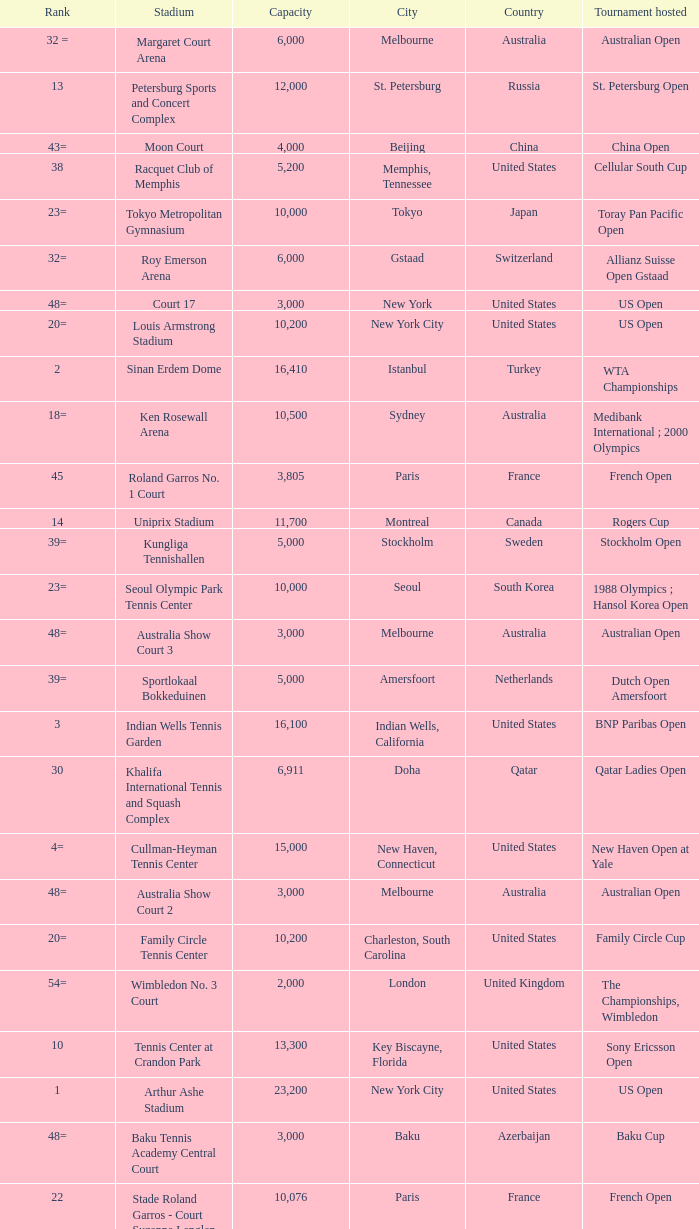Can you parse all the data within this table? {'header': ['Rank', 'Stadium', 'Capacity', 'City', 'Country', 'Tournament hosted'], 'rows': [['32 =', 'Margaret Court Arena', '6,000', 'Melbourne', 'Australia', 'Australian Open'], ['13', 'Petersburg Sports and Concert Complex', '12,000', 'St. Petersburg', 'Russia', 'St. Petersburg Open'], ['43=', 'Moon Court', '4,000', 'Beijing', 'China', 'China Open'], ['38', 'Racquet Club of Memphis', '5,200', 'Memphis, Tennessee', 'United States', 'Cellular South Cup'], ['23=', 'Tokyo Metropolitan Gymnasium', '10,000', 'Tokyo', 'Japan', 'Toray Pan Pacific Open'], ['32=', 'Roy Emerson Arena', '6,000', 'Gstaad', 'Switzerland', 'Allianz Suisse Open Gstaad'], ['48=', 'Court 17', '3,000', 'New York', 'United States', 'US Open'], ['20=', 'Louis Armstrong Stadium', '10,200', 'New York City', 'United States', 'US Open'], ['2', 'Sinan Erdem Dome', '16,410', 'Istanbul', 'Turkey', 'WTA Championships'], ['18=', 'Ken Rosewall Arena', '10,500', 'Sydney', 'Australia', 'Medibank International ; 2000 Olympics'], ['45', 'Roland Garros No. 1 Court', '3,805', 'Paris', 'France', 'French Open'], ['14', 'Uniprix Stadium', '11,700', 'Montreal', 'Canada', 'Rogers Cup'], ['39=', 'Kungliga Tennishallen', '5,000', 'Stockholm', 'Sweden', 'Stockholm Open'], ['23=', 'Seoul Olympic Park Tennis Center', '10,000', 'Seoul', 'South Korea', '1988 Olympics ; Hansol Korea Open'], ['48=', 'Australia Show Court 3', '3,000', 'Melbourne', 'Australia', 'Australian Open'], ['39=', 'Sportlokaal Bokkeduinen', '5,000', 'Amersfoort', 'Netherlands', 'Dutch Open Amersfoort'], ['3', 'Indian Wells Tennis Garden', '16,100', 'Indian Wells, California', 'United States', 'BNP Paribas Open'], ['30', 'Khalifa International Tennis and Squash Complex', '6,911', 'Doha', 'Qatar', 'Qatar Ladies Open'], ['4=', 'Cullman-Heyman Tennis Center', '15,000', 'New Haven, Connecticut', 'United States', 'New Haven Open at Yale'], ['48=', 'Australia Show Court 2', '3,000', 'Melbourne', 'Australia', 'Australian Open'], ['20=', 'Family Circle Tennis Center', '10,200', 'Charleston, South Carolina', 'United States', 'Family Circle Cup'], ['54=', 'Wimbledon No. 3 Court', '2,000', 'London', 'United Kingdom', 'The Championships, Wimbledon'], ['10', 'Tennis Center at Crandon Park', '13,300', 'Key Biscayne, Florida', 'United States', 'Sony Ericsson Open'], ['1', 'Arthur Ashe Stadium', '23,200', 'New York City', 'United States', 'US Open'], ['48=', 'Baku Tennis Academy Central Court', '3,000', 'Baku', 'Azerbaijan', 'Baku Cup'], ['22', 'Stade Roland Garros - Court Suzanne Lenglen', '10,076', 'Paris', 'France', 'French Open'], ['10=', 'Foro Italico, Campo Centrale', '12,500', 'Rome', 'Italy', "Internazionali d'Italia"], ['23=', 'Estoril Court Central', '10,000', 'Oeiras', 'Portugal', 'Estoril Open'], ['54=', 'National Tennis Center Court 1', '2,000', 'Beijing', 'China', 'China Open'], ['53', 'Hobart International Tennis Centre', '2,500', 'Hobart', 'Australia', 'Hobart International'], ['18=', 'Hisense Arena', '10,500', 'Melbourne', 'Australia', 'Australian Open'], ['27', 'Ariake Coliseum', '9,000', 'Tokyo', 'Japan', 'Japan Open Tennis Championships'], ['29', 'Steffi-Graf-Stadion', '7,000', 'Berlin', 'Germany', 'Qatar Telecom German Open'], ['15', 'Wimbledon No. 1 Court', '11,429', 'London', 'United Kingdom', 'The Championships, Wimbledon'], ['46', 'Darling Tennis Center', '3,500', 'Las Vegas, Nevada', 'United States', 'Tennis Channel Open'], ['39=', 'Dubai Tennis Stadium', '5,000', 'Dubai', 'United Arab Emirates', 'Dubai Tennis Championships'], ['16=', 'Lindner Family Tennis Center', '11,400', 'Mason, Ohio', 'United States', 'W&SFG Masters'], ['7', 'Stade Roland Garros - Court Philippe Chatrier', '14,911', 'Paris', 'France', 'French Open'], ['47', 'ASB Centre', '3,200', 'Auckland', 'New Zealand', 'ASB Classic'], ['4=', 'Wimbledon Centre Court [a ]', '15,000', 'London', 'United Kingdom', 'The Championships, Wimbledon'], ['36', 'Intersport Arena', '5,699', 'Linz', 'Austria', 'Generali Ladies Linz'], ['39=', 'Guangzhou International Tennis Center', '5,000', 'Guangzhou', 'China', "Guangzhou International Women's Open"], ['16=', 'Olympic Stadium', '11,400', 'Moscow', 'Russia', 'Kremlin Cup'], ['32 =', 'Fairmont Acapulco Princess', '6,000', 'Acapulco', 'Mexico', 'Abierto Mexicano Telcel'], ['43=', 'Wimbledon No. 2 Court', '4,000', 'London', 'United Kingdom', 'The Championships, Wimbledon'], ['37', 'Pat Rafter Arena', '5,500', 'Brisbane', 'Australia', 'Brisbane International'], ['48=', 'Római Teniszakadémia', '3,000', 'Budapest', 'Hungary', 'Budapest Grand Prix'], ['8', 'Rod Laver Arena', '14,820', 'Melbourne', 'Australia', 'Australian Open'], ['10=', 'Caja Mágica, Estadio Manolo Santana', '12,500', 'Madrid', 'Spain', 'Madrid Masters'], ['10=', 'Rexall Centre', '12,500', 'Toronto', 'Canada', 'Rogers Cup'], ['9', 'Armeets Arena', '13,545', 'Sofia', 'Bulgaria', 'WTA Tournament of Champions (2012–13)'], ['23=', 'Lotus Court', '10,000', 'Beijing', 'China', 'China Open ; 2008 Olympics'], ['4=', 'National Tennis Stadium', '15,000', 'Beijing', 'China', 'China Open ; 2008 Olympics'], ['31', 'Porsche Arena', '6,100', 'Stuttgart', 'Germany', 'Porsche Tennis Grand Prix'], ['39=', 'Båstad Tennis Stadium', '5,000', 'Båstad', 'Sweden', 'Swedish Open'], ['28', 'Devonshire Park Lawn Tennis Club', '8,000', 'Eastbourne', 'United Kingdom', 'Eastbourne International'], ['32=', 'Grandstand Stadium', '6,000', 'New York City', 'United States', 'US Open']]} What is the average capacity that has rod laver arena as the stadium? 14820.0. 